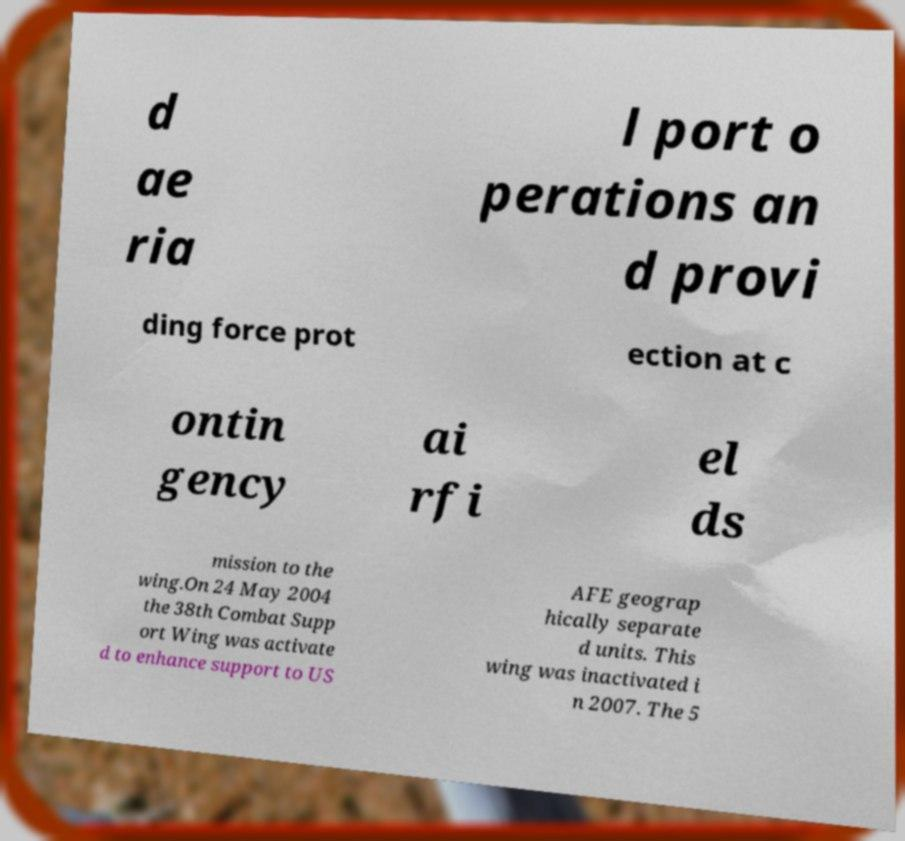Could you assist in decoding the text presented in this image and type it out clearly? d ae ria l port o perations an d provi ding force prot ection at c ontin gency ai rfi el ds mission to the wing.On 24 May 2004 the 38th Combat Supp ort Wing was activate d to enhance support to US AFE geograp hically separate d units. This wing was inactivated i n 2007. The 5 